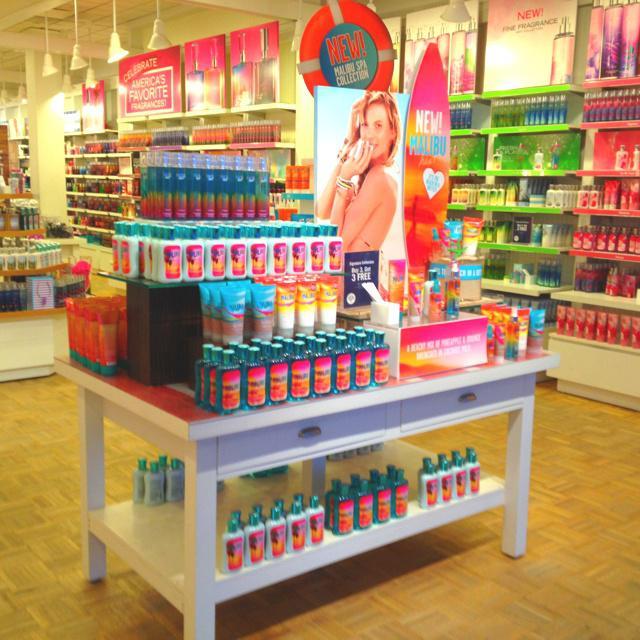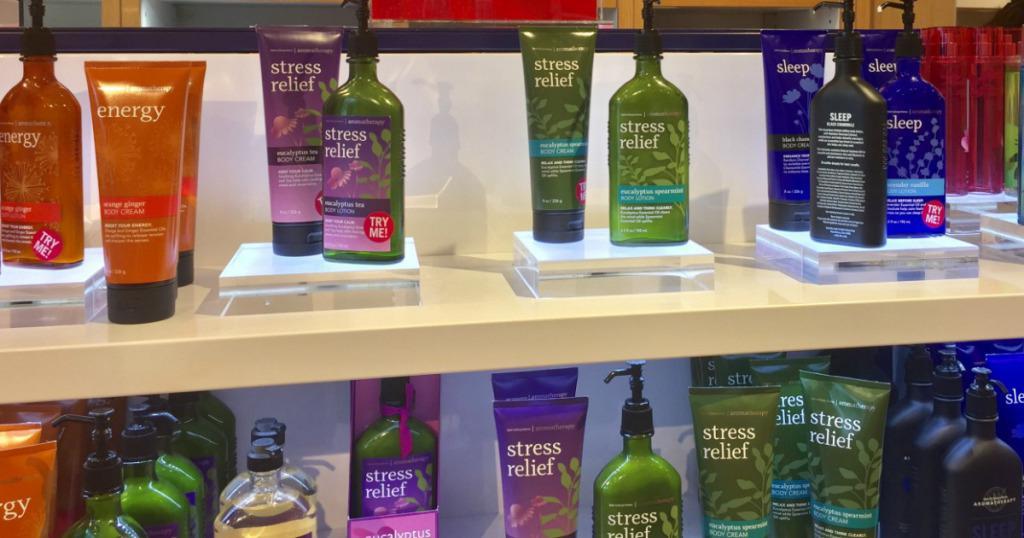The first image is the image on the left, the second image is the image on the right. For the images displayed, is the sentence "There are at least two people in one of the iamges." factually correct? Answer yes or no. No. 